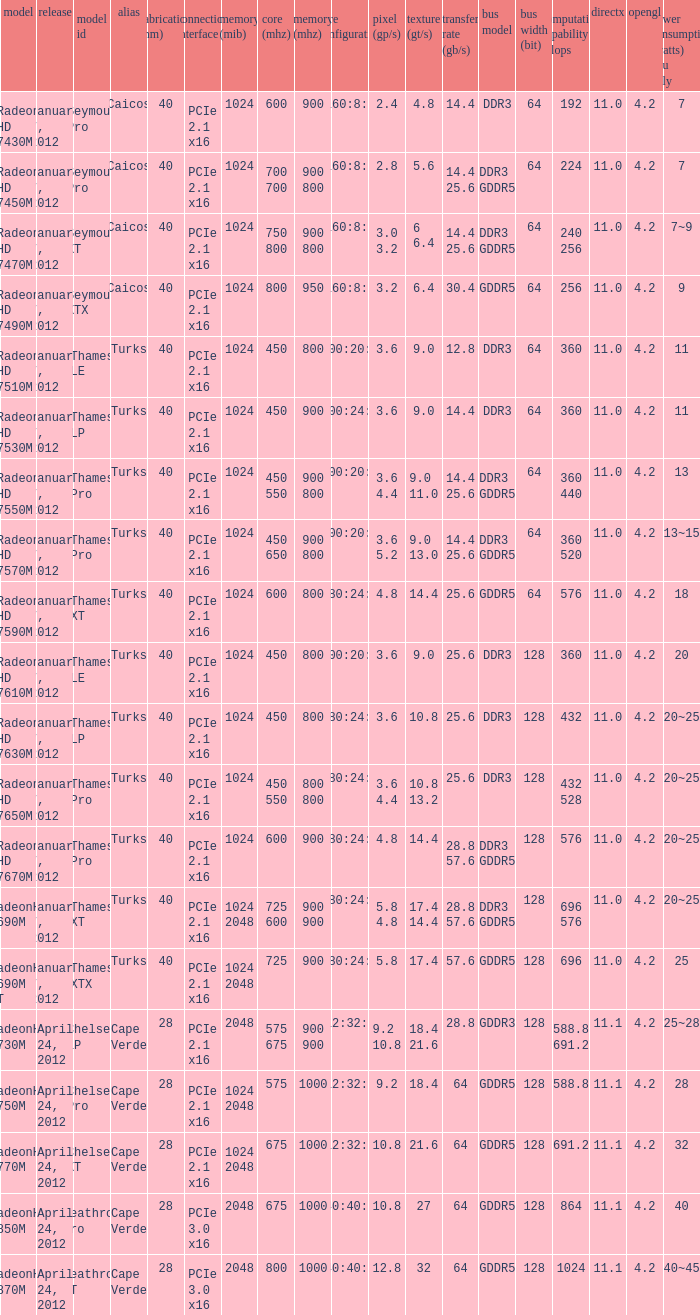What is the config core 1 of the model with a processing power GFLOPs of 432? 480:24:8. 